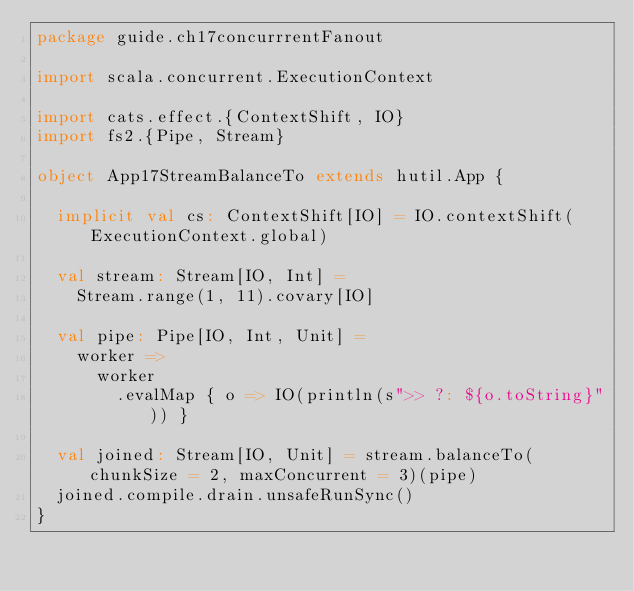<code> <loc_0><loc_0><loc_500><loc_500><_Scala_>package guide.ch17concurrrentFanout

import scala.concurrent.ExecutionContext

import cats.effect.{ContextShift, IO}
import fs2.{Pipe, Stream}

object App17StreamBalanceTo extends hutil.App {

  implicit val cs: ContextShift[IO] = IO.contextShift(ExecutionContext.global)

  val stream: Stream[IO, Int] =
    Stream.range(1, 11).covary[IO]

  val pipe: Pipe[IO, Int, Unit] =
    worker =>
      worker
        .evalMap { o => IO(println(s">> ?: ${o.toString}")) }

  val joined: Stream[IO, Unit] = stream.balanceTo(chunkSize = 2, maxConcurrent = 3)(pipe)
  joined.compile.drain.unsafeRunSync()
}
</code> 